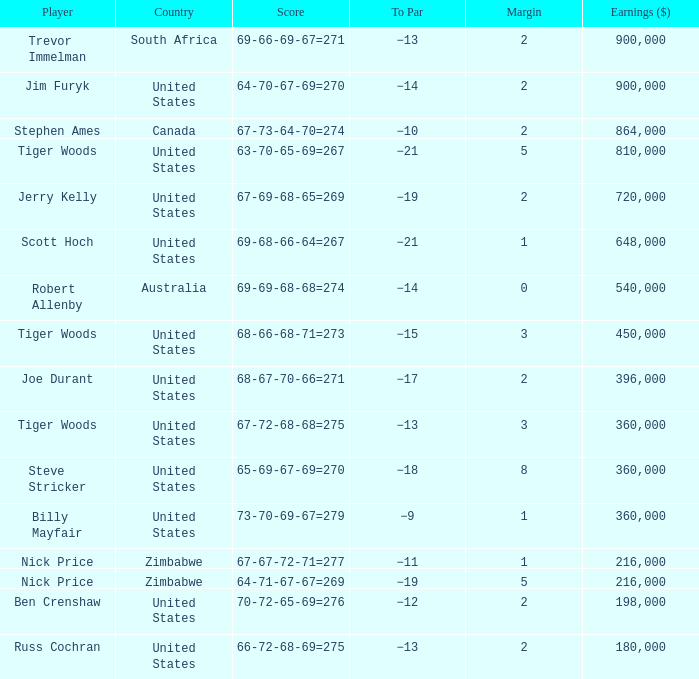What is canada's edge? 2.0. 